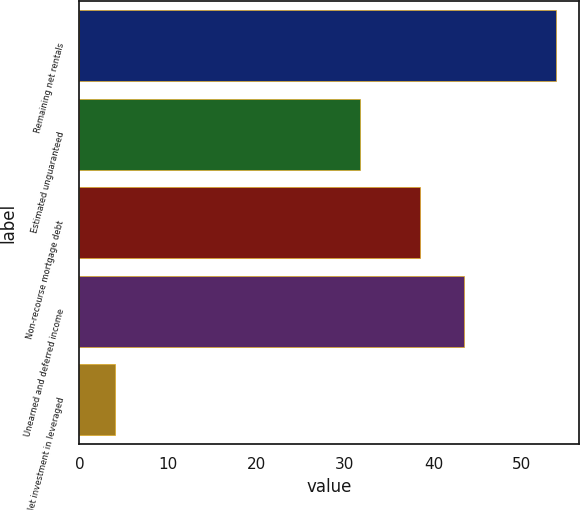Convert chart. <chart><loc_0><loc_0><loc_500><loc_500><bar_chart><fcel>Remaining net rentals<fcel>Estimated unguaranteed<fcel>Non-recourse mortgage debt<fcel>Unearned and deferred income<fcel>Net investment in leveraged<nl><fcel>53.8<fcel>31.7<fcel>38.5<fcel>43.48<fcel>4<nl></chart> 